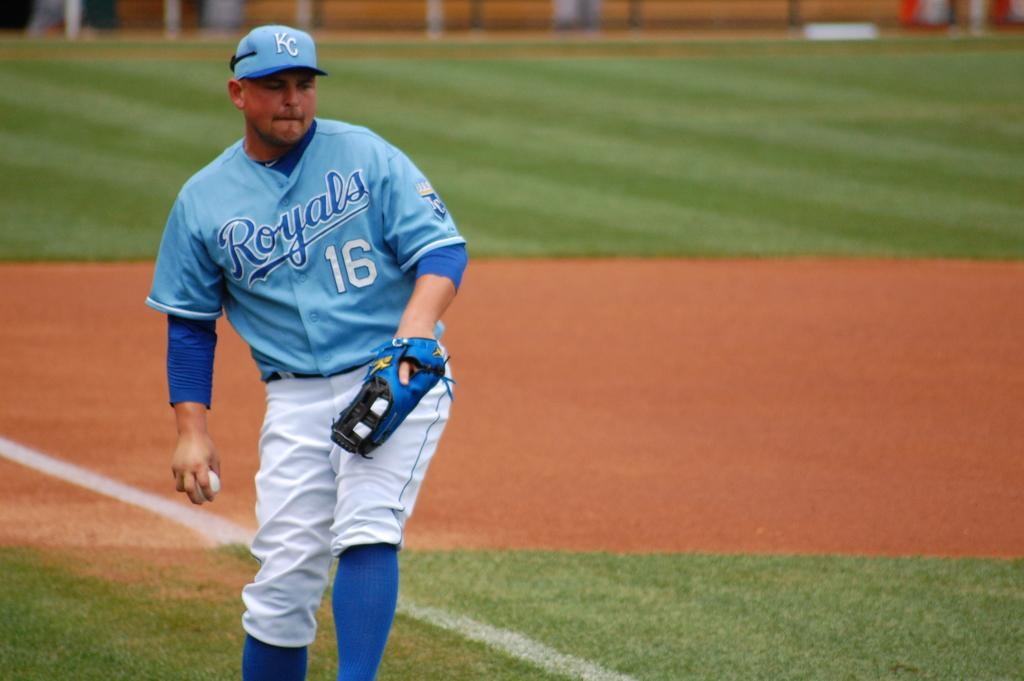<image>
Offer a succinct explanation of the picture presented. Number sixteen for the Royals prepares to throw a baseball. 